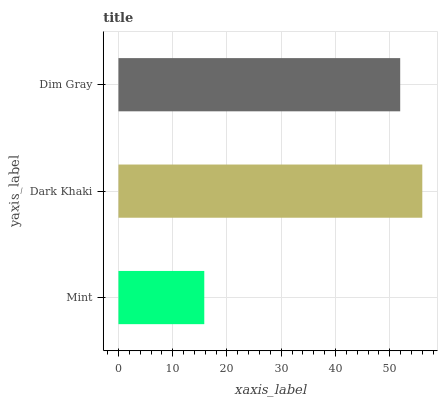Is Mint the minimum?
Answer yes or no. Yes. Is Dark Khaki the maximum?
Answer yes or no. Yes. Is Dim Gray the minimum?
Answer yes or no. No. Is Dim Gray the maximum?
Answer yes or no. No. Is Dark Khaki greater than Dim Gray?
Answer yes or no. Yes. Is Dim Gray less than Dark Khaki?
Answer yes or no. Yes. Is Dim Gray greater than Dark Khaki?
Answer yes or no. No. Is Dark Khaki less than Dim Gray?
Answer yes or no. No. Is Dim Gray the high median?
Answer yes or no. Yes. Is Dim Gray the low median?
Answer yes or no. Yes. Is Dark Khaki the high median?
Answer yes or no. No. Is Dark Khaki the low median?
Answer yes or no. No. 